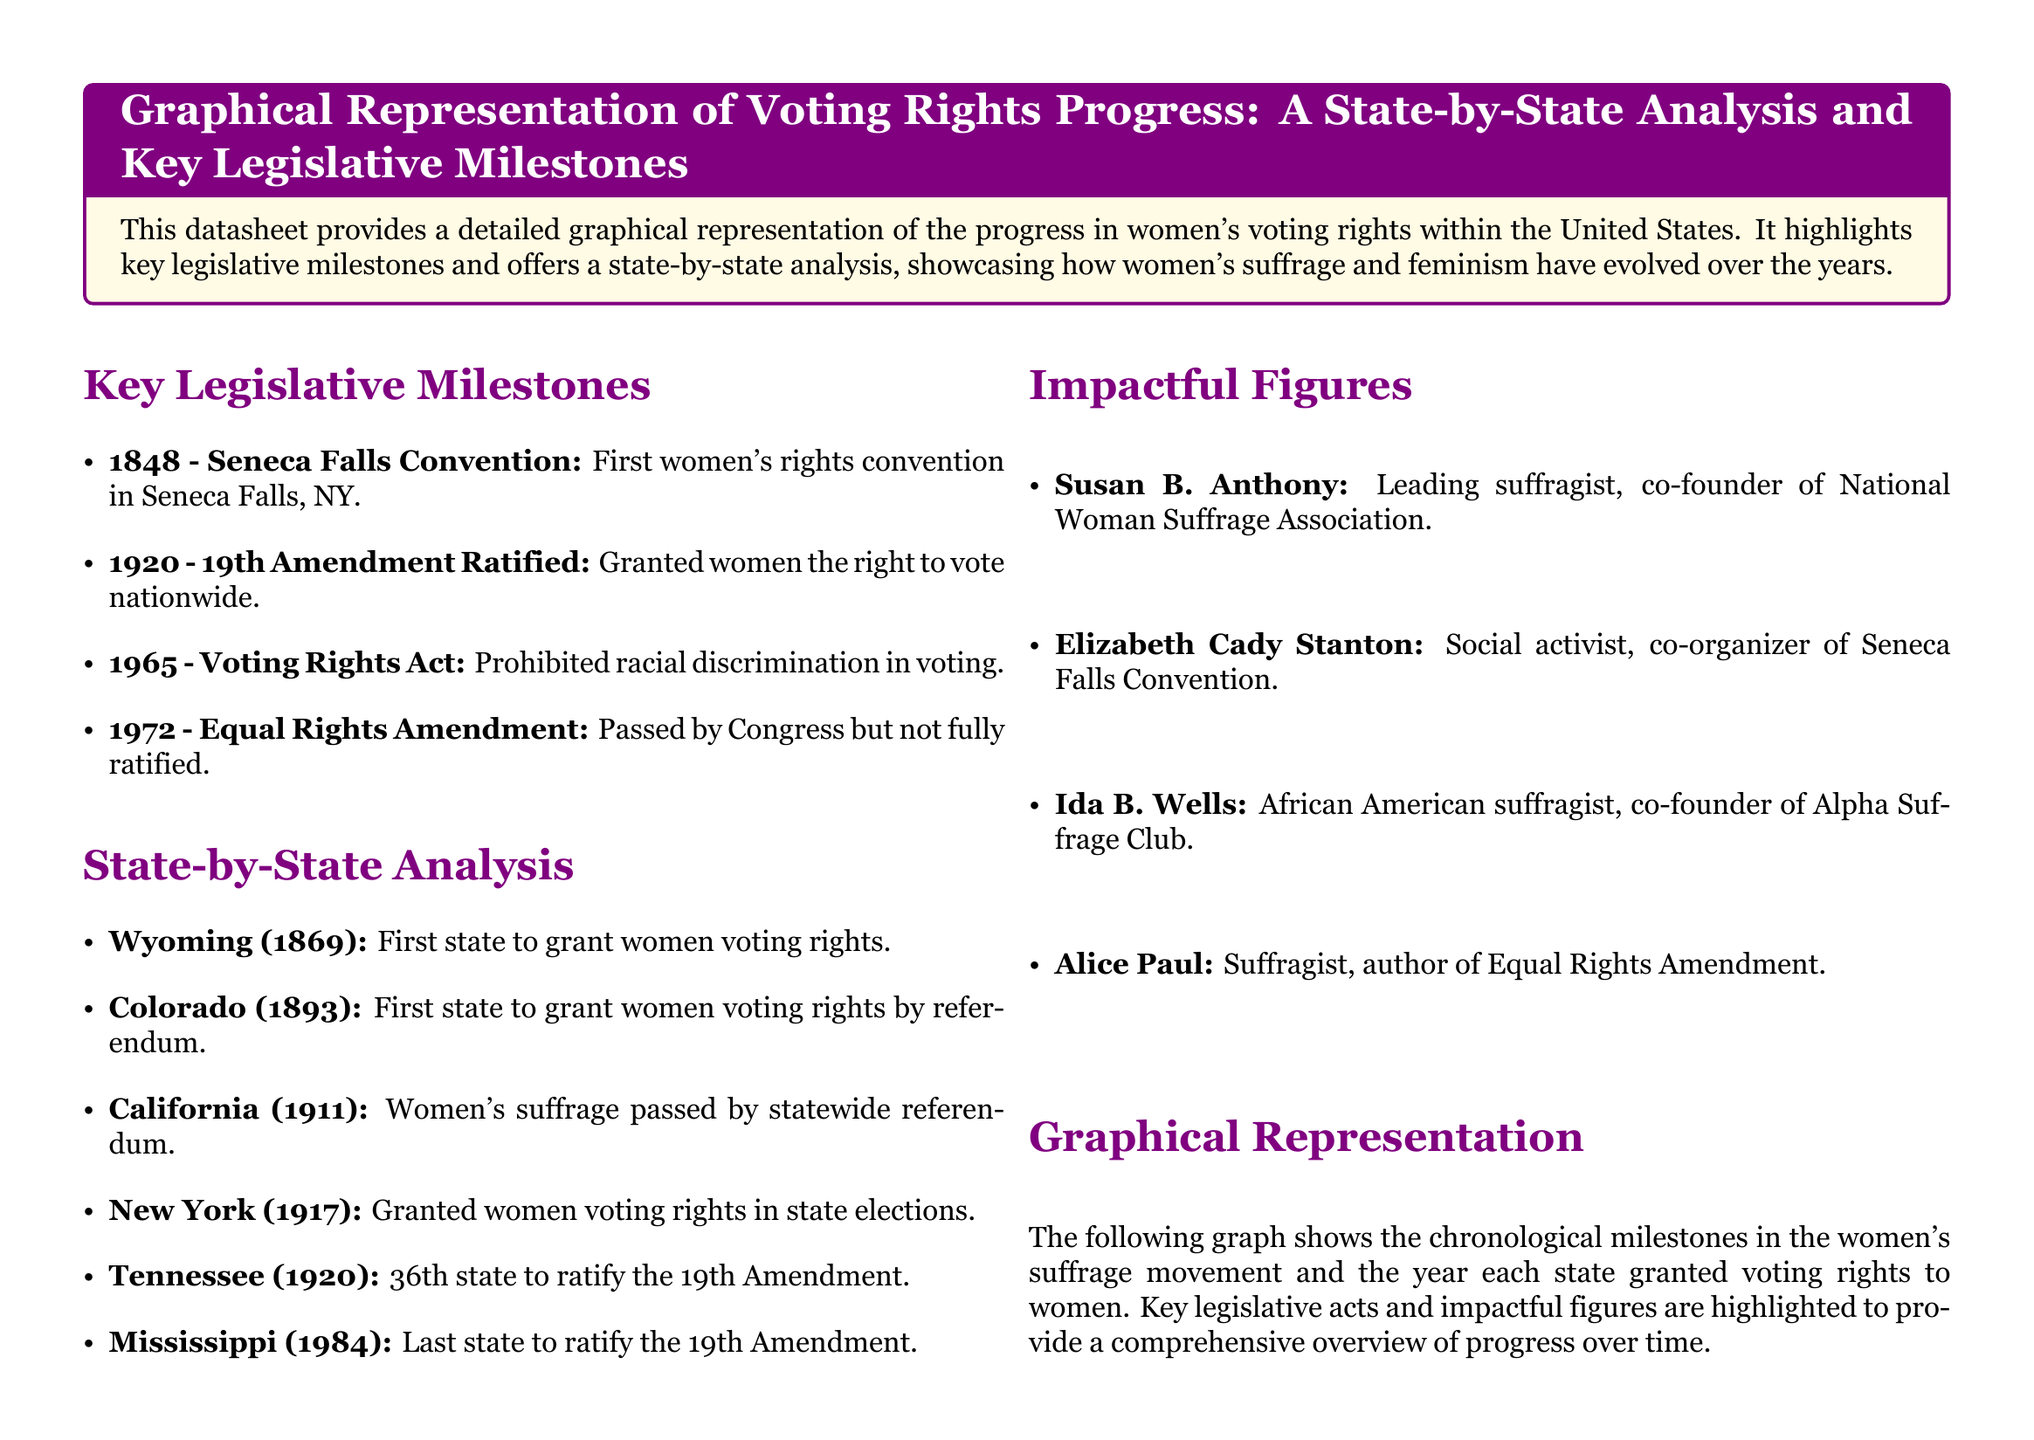What year was the Seneca Falls Convention held? The Seneca Falls Convention was held in 1848, as listed in the key legislative milestones section.
Answer: 1848 Which state was the first to grant women voting rights? Wyoming is noted as the first state to grant women voting rights in the state-by-state analysis.
Answer: Wyoming What major legislative act was passed in 1965? The Voting Rights Act, which prohibited racial discrimination in voting, was passed in 1965.
Answer: Voting Rights Act Who was a co-founder of the National Woman Suffrage Association? Susan B. Anthony is identified as a leading suffragist and co-founder of the National Woman Suffrage Association.
Answer: Susan B. Anthony What significant milestone occurred in 1920? The ratification of the 19th Amendment, which granted women the right to vote nationwide, occurred in 1920.
Answer: 19th Amendment Ratified Which state was the last to ratify the 19th Amendment? The document states that Mississippi was the last state to ratify the 19th Amendment in 1984.
Answer: Mississippi How many states are listed as granting women voting rights before the 19th Amendment was ratified? The state-by-state analysis mentions five states that granted women voting rights before the 19th Amendment was ratified.
Answer: Five Who authored the Equal Rights Amendment? Alice Paul is mentioned as the suffragist who authored the Equal Rights Amendment in the impactful figures section.
Answer: Alice Paul What year did Colorado grant women voting rights? According to the state-by-state analysis, Colorado granted women voting rights in 1893.
Answer: 1893 